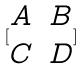<formula> <loc_0><loc_0><loc_500><loc_500>[ \begin{matrix} A & B \\ C & D \end{matrix} ]</formula> 